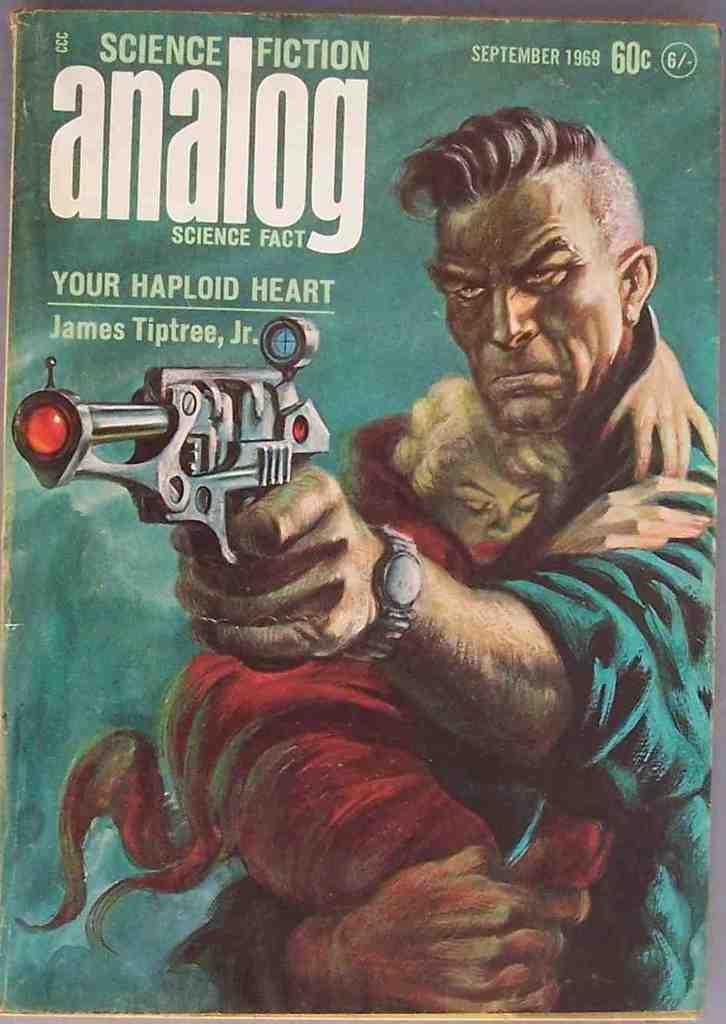Please provide a concise description of this image. In this picture I can observe a poster. I can observe some text in this poster. On the right side I can observe a person holding a gun in this poster. The background is in green color. 